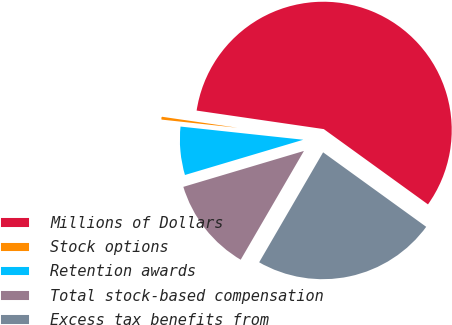<chart> <loc_0><loc_0><loc_500><loc_500><pie_chart><fcel>Millions of Dollars<fcel>Stock options<fcel>Retention awards<fcel>Total stock-based compensation<fcel>Excess tax benefits from<nl><fcel>57.65%<fcel>0.6%<fcel>6.31%<fcel>12.01%<fcel>23.42%<nl></chart> 